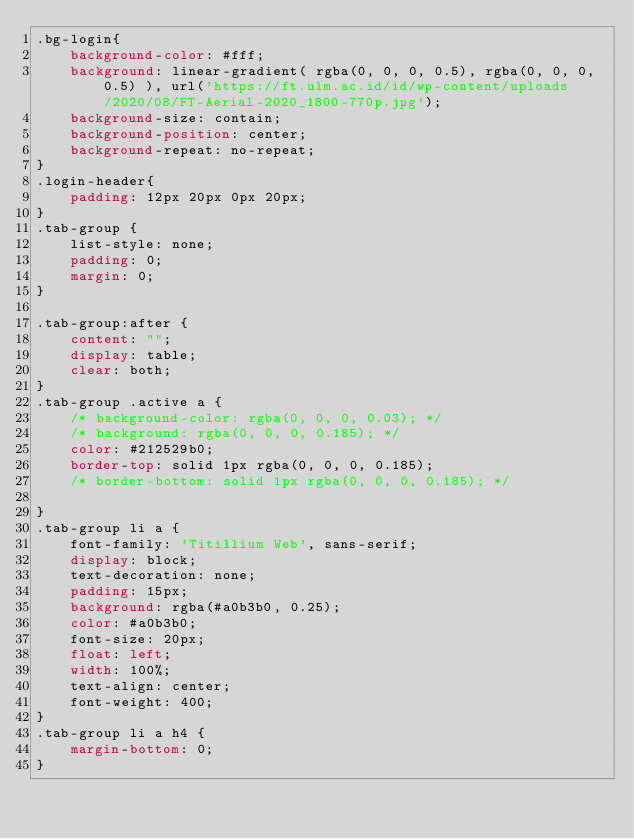Convert code to text. <code><loc_0><loc_0><loc_500><loc_500><_CSS_>.bg-login{
    background-color: #fff;
    background: linear-gradient( rgba(0, 0, 0, 0.5), rgba(0, 0, 0, 0.5) ), url('https://ft.ulm.ac.id/id/wp-content/uploads/2020/08/FT-Aerial-2020_1800-770p.jpg');
    background-size: contain;
    background-position: center;
    background-repeat: no-repeat;
}
.login-header{
    padding: 12px 20px 0px 20px;
}
.tab-group {
    list-style: none;
    padding: 0;
    margin: 0;
}

.tab-group:after {
    content: "";
    display: table;
    clear: both;
}
.tab-group .active a {
    /* background-color: rgba(0, 0, 0, 0.03); */
    /* background: rgba(0, 0, 0, 0.185); */
    color: #212529b0;
    border-top: solid 1px rgba(0, 0, 0, 0.185);
    /* border-bottom: solid 1px rgba(0, 0, 0, 0.185); */
   
}
.tab-group li a {
    font-family: 'Titillium Web', sans-serif;
    display: block;
    text-decoration: none;
    padding: 15px;
    background: rgba(#a0b3b0, 0.25);
    color: #a0b3b0;
    font-size: 20px;
    float: left;
    width: 100%;
    text-align: center;
    font-weight: 400;
}
.tab-group li a h4 {
    margin-bottom: 0;
}
</code> 